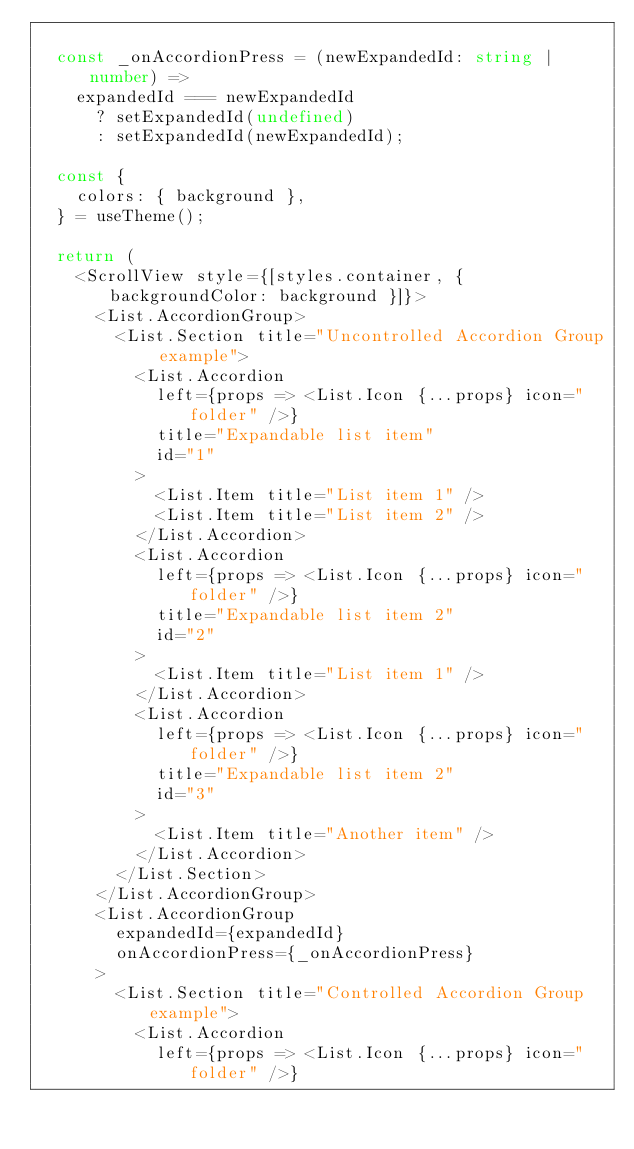Convert code to text. <code><loc_0><loc_0><loc_500><loc_500><_TypeScript_>
  const _onAccordionPress = (newExpandedId: string | number) =>
    expandedId === newExpandedId
      ? setExpandedId(undefined)
      : setExpandedId(newExpandedId);

  const {
    colors: { background },
  } = useTheme();

  return (
    <ScrollView style={[styles.container, { backgroundColor: background }]}>
      <List.AccordionGroup>
        <List.Section title="Uncontrolled Accordion Group example">
          <List.Accordion
            left={props => <List.Icon {...props} icon="folder" />}
            title="Expandable list item"
            id="1"
          >
            <List.Item title="List item 1" />
            <List.Item title="List item 2" />
          </List.Accordion>
          <List.Accordion
            left={props => <List.Icon {...props} icon="folder" />}
            title="Expandable list item 2"
            id="2"
          >
            <List.Item title="List item 1" />
          </List.Accordion>
          <List.Accordion
            left={props => <List.Icon {...props} icon="folder" />}
            title="Expandable list item 2"
            id="3"
          >
            <List.Item title="Another item" />
          </List.Accordion>
        </List.Section>
      </List.AccordionGroup>
      <List.AccordionGroup
        expandedId={expandedId}
        onAccordionPress={_onAccordionPress}
      >
        <List.Section title="Controlled Accordion Group example">
          <List.Accordion
            left={props => <List.Icon {...props} icon="folder" />}</code> 